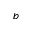<formula> <loc_0><loc_0><loc_500><loc_500>^ { b }</formula> 